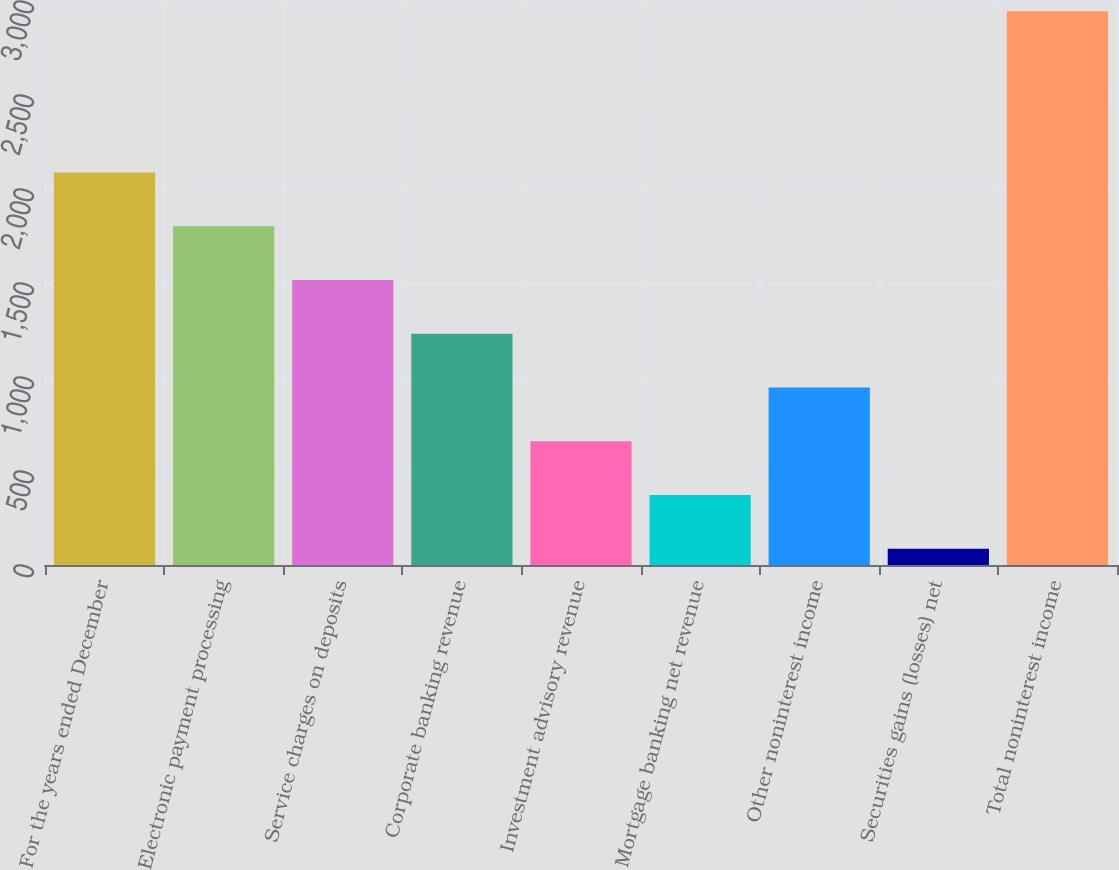Convert chart. <chart><loc_0><loc_0><loc_500><loc_500><bar_chart><fcel>For the years ended December<fcel>Electronic payment processing<fcel>Service charges on deposits<fcel>Corporate banking revenue<fcel>Investment advisory revenue<fcel>Mortgage banking net revenue<fcel>Other noninterest income<fcel>Securities gains (losses) net<fcel>Total noninterest income<nl><fcel>2088<fcel>1802<fcel>1516<fcel>1230<fcel>658<fcel>372<fcel>944<fcel>86<fcel>2946<nl></chart> 